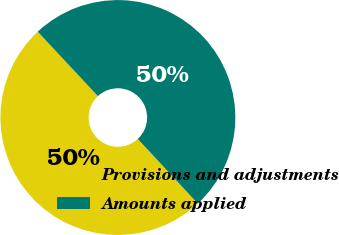<chart> <loc_0><loc_0><loc_500><loc_500><pie_chart><fcel>Provisions and adjustments<fcel>Amounts applied<nl><fcel>49.96%<fcel>50.04%<nl></chart> 